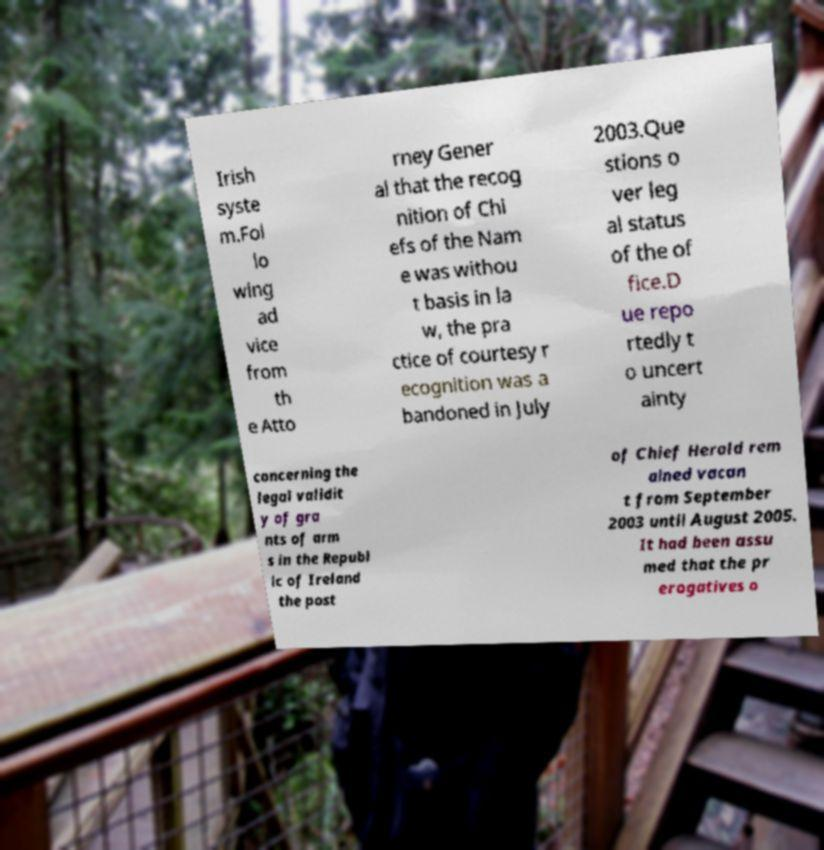Could you assist in decoding the text presented in this image and type it out clearly? Irish syste m.Fol lo wing ad vice from th e Atto rney Gener al that the recog nition of Chi efs of the Nam e was withou t basis in la w, the pra ctice of courtesy r ecognition was a bandoned in July 2003.Que stions o ver leg al status of the of fice.D ue repo rtedly t o uncert ainty concerning the legal validit y of gra nts of arm s in the Republ ic of Ireland the post of Chief Herald rem ained vacan t from September 2003 until August 2005. It had been assu med that the pr erogatives o 